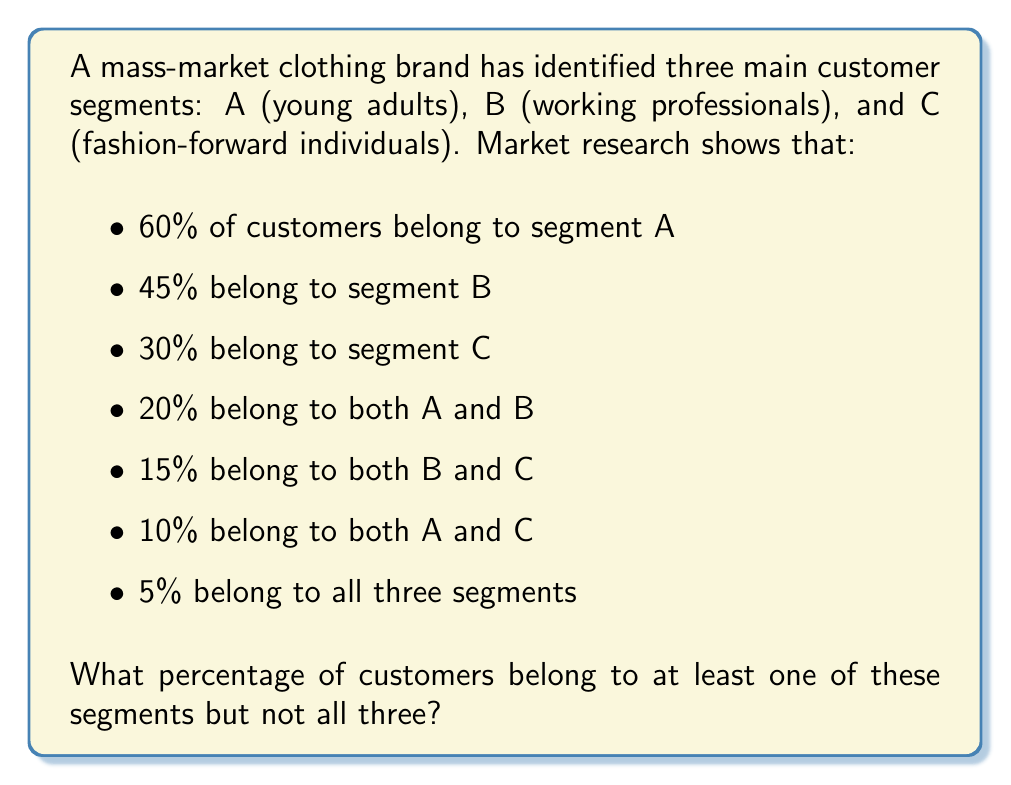Show me your answer to this math problem. To solve this problem, we'll use set theory principles, specifically the inclusion-exclusion principle.

Let's define our sets:
$A$: young adults
$B$: working professionals
$C$: fashion-forward individuals

We're given:
$|A| = 60\%$, $|B| = 45\%$, $|C| = 30\%$
$|A \cap B| = 20\%$, $|B \cap C| = 15\%$, $|A \cap C| = 10\%$
$|A \cap B \cap C| = 5\%$

We need to find $|A \cup B \cup C| - |A \cap B \cap C|$

Using the inclusion-exclusion principle:

$$|A \cup B \cup C| = |A| + |B| + |C| - |A \cap B| - |B \cap C| - |A \cap C| + |A \cap B \cap C|$$

Substituting the given values:

$$|A \cup B \cup C| = 60\% + 45\% + 30\% - 20\% - 15\% - 10\% + 5\% = 95\%$$

Now, to find the percentage of customers belonging to at least one segment but not all three:

$$95\% - 5\% = 90\%$$
Answer: 90% 